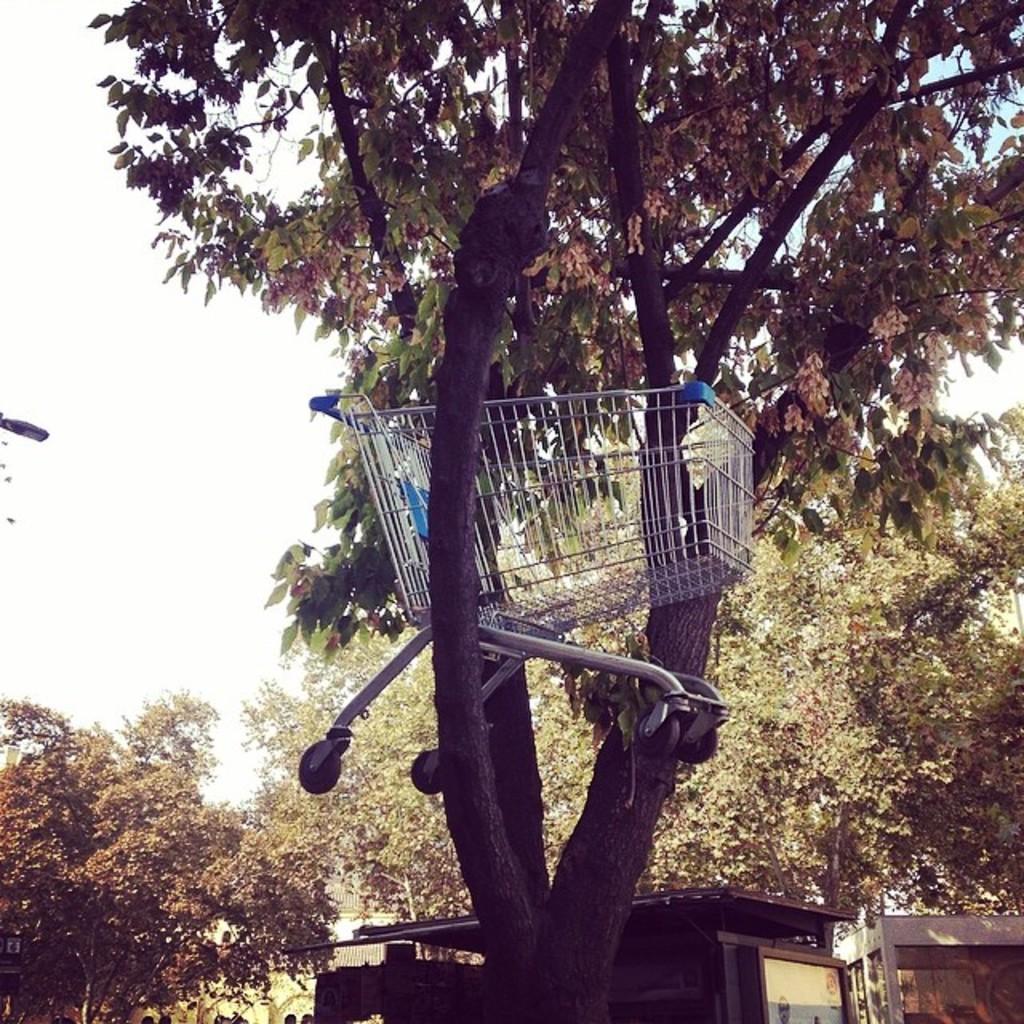Describe this image in one or two sentences. In this picture I can see a trolley, which is on a tree. In the background I can see few more trees and few buildings and I can also see the sky. 